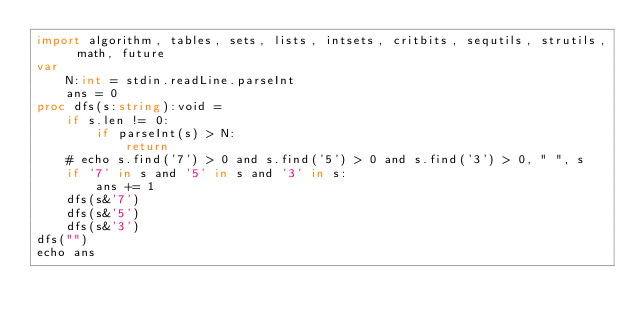Convert code to text. <code><loc_0><loc_0><loc_500><loc_500><_Nim_>import algorithm, tables, sets, lists, intsets, critbits, sequtils, strutils, math, future
var
    N:int = stdin.readLine.parseInt
    ans = 0
proc dfs(s:string):void =
    if s.len != 0:
        if parseInt(s) > N:
            return
    # echo s.find('7') > 0 and s.find('5') > 0 and s.find('3') > 0, " ", s
    if '7' in s and '5' in s and '3' in s:
        ans += 1
    dfs(s&'7')
    dfs(s&'5')
    dfs(s&'3')
dfs("")
echo ans</code> 